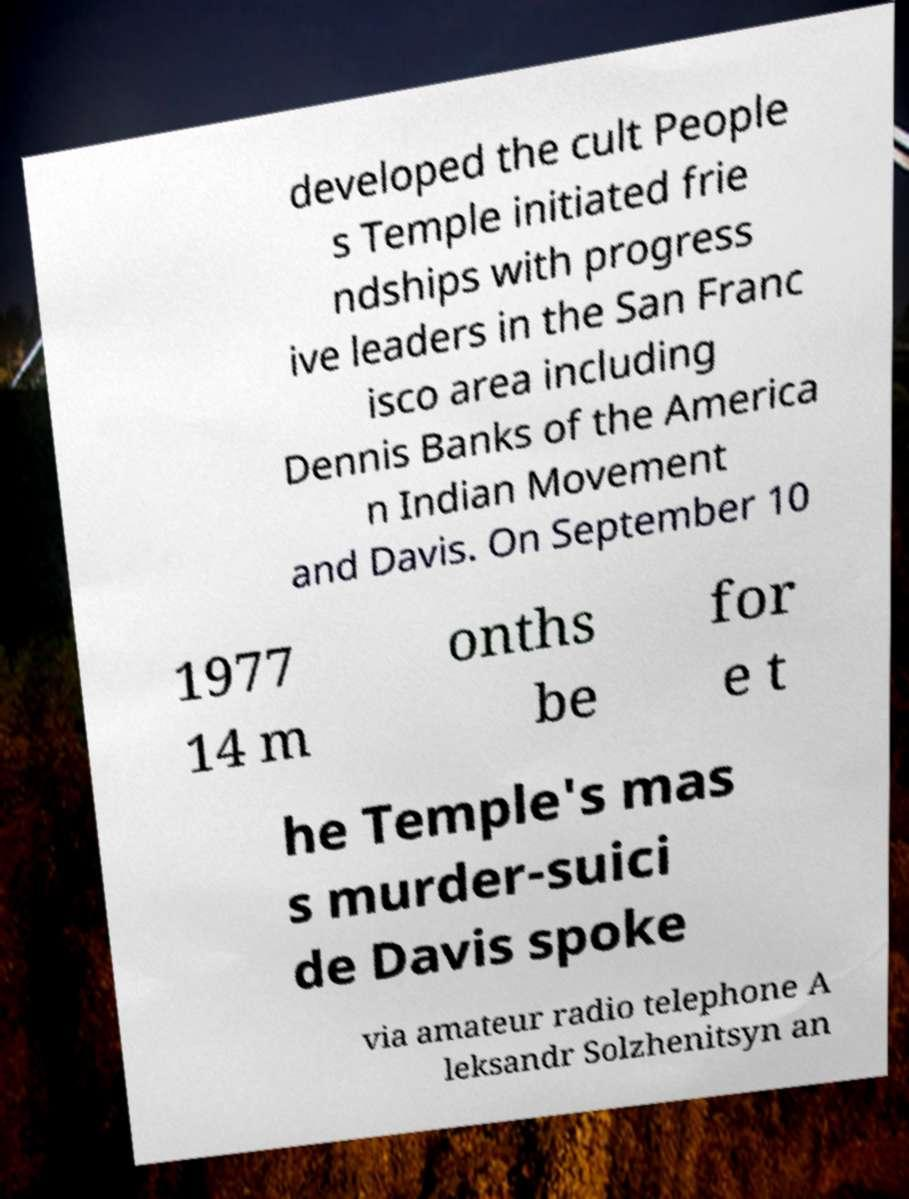What messages or text are displayed in this image? I need them in a readable, typed format. developed the cult People s Temple initiated frie ndships with progress ive leaders in the San Franc isco area including Dennis Banks of the America n Indian Movement and Davis. On September 10 1977 14 m onths be for e t he Temple's mas s murder-suici de Davis spoke via amateur radio telephone A leksandr Solzhenitsyn an 